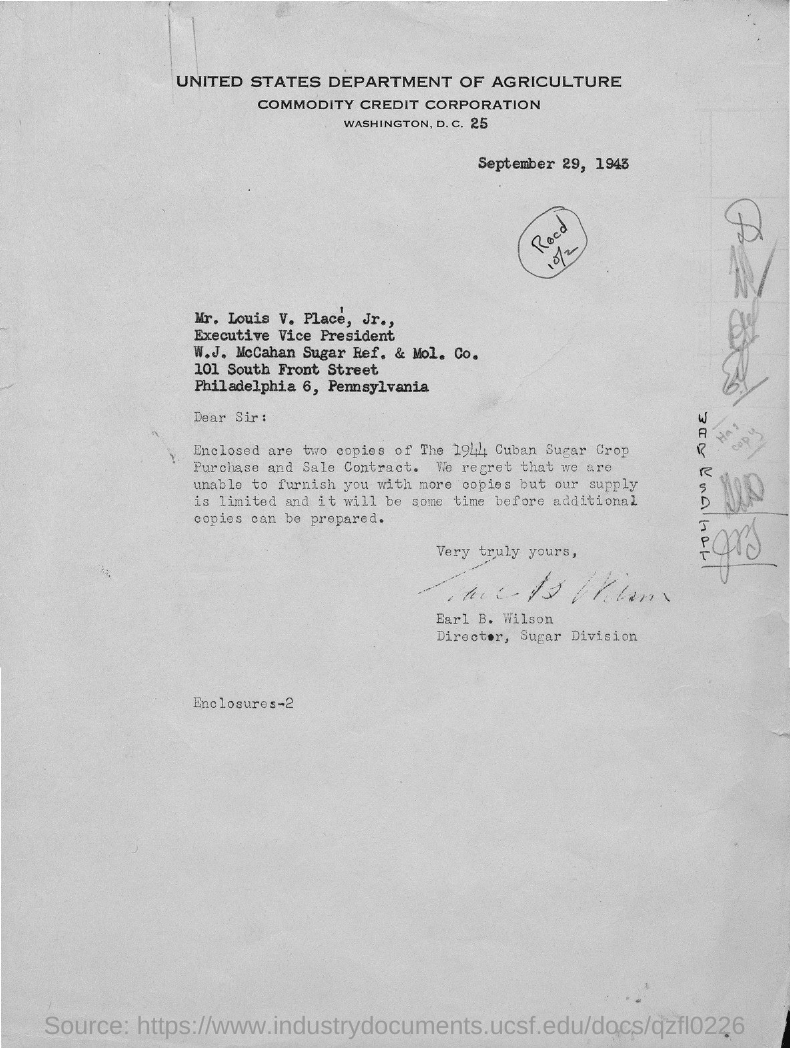What is the issued date of this letter?
Provide a short and direct response. September 29, 1943. Who is the sender of this letter?
Keep it short and to the point. Earl B. Wilson. Who is the addressee of this letter?
Make the answer very short. Mr. Louis V. Place. What is the designation of Mr. Louis V. Place' Jr.?
Ensure brevity in your answer.  Executive Vice President. 